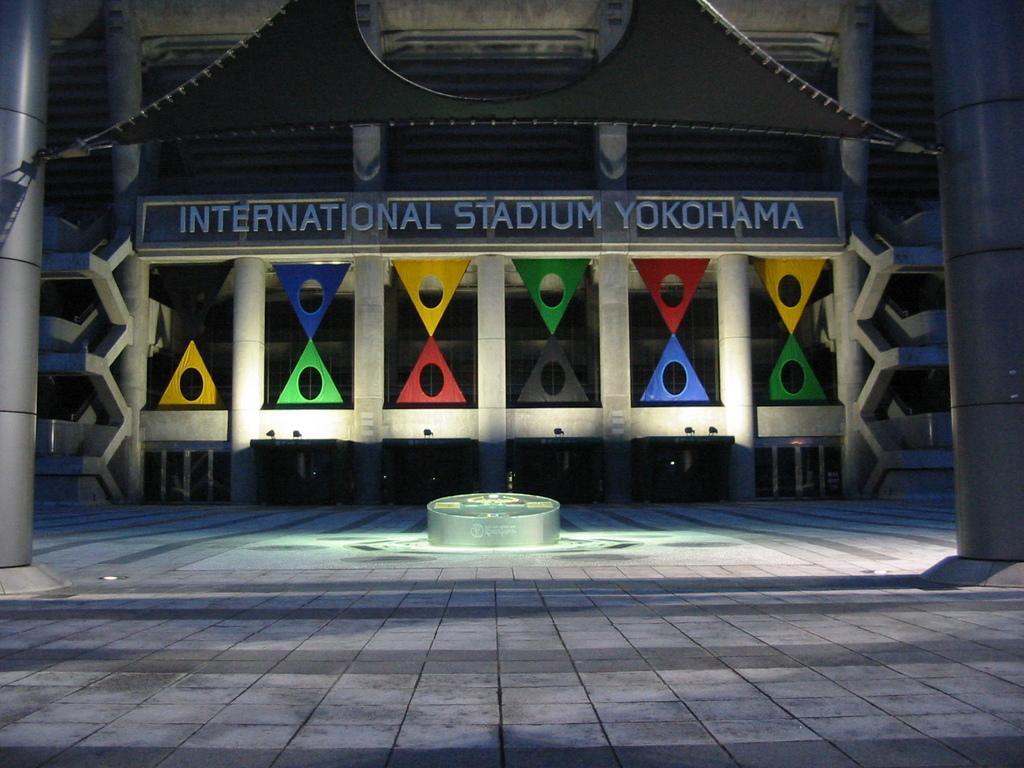Could you give a brief overview of what you see in this image? In this image we can see one stadium. One big wall is there some text is there on the wall. The stadium is decorated with colorful triangles , two poles are there. 